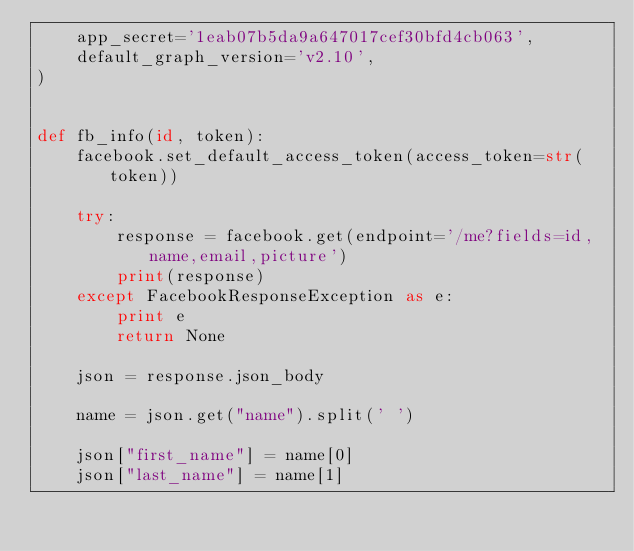<code> <loc_0><loc_0><loc_500><loc_500><_Python_>    app_secret='1eab07b5da9a647017cef30bfd4cb063',
    default_graph_version='v2.10',
)


def fb_info(id, token):
    facebook.set_default_access_token(access_token=str(token))

    try:
        response = facebook.get(endpoint='/me?fields=id,name,email,picture')
        print(response)
    except FacebookResponseException as e:
        print e
        return None

    json = response.json_body

    name = json.get("name").split(' ')

    json["first_name"] = name[0]
    json["last_name"] = name[1]</code> 